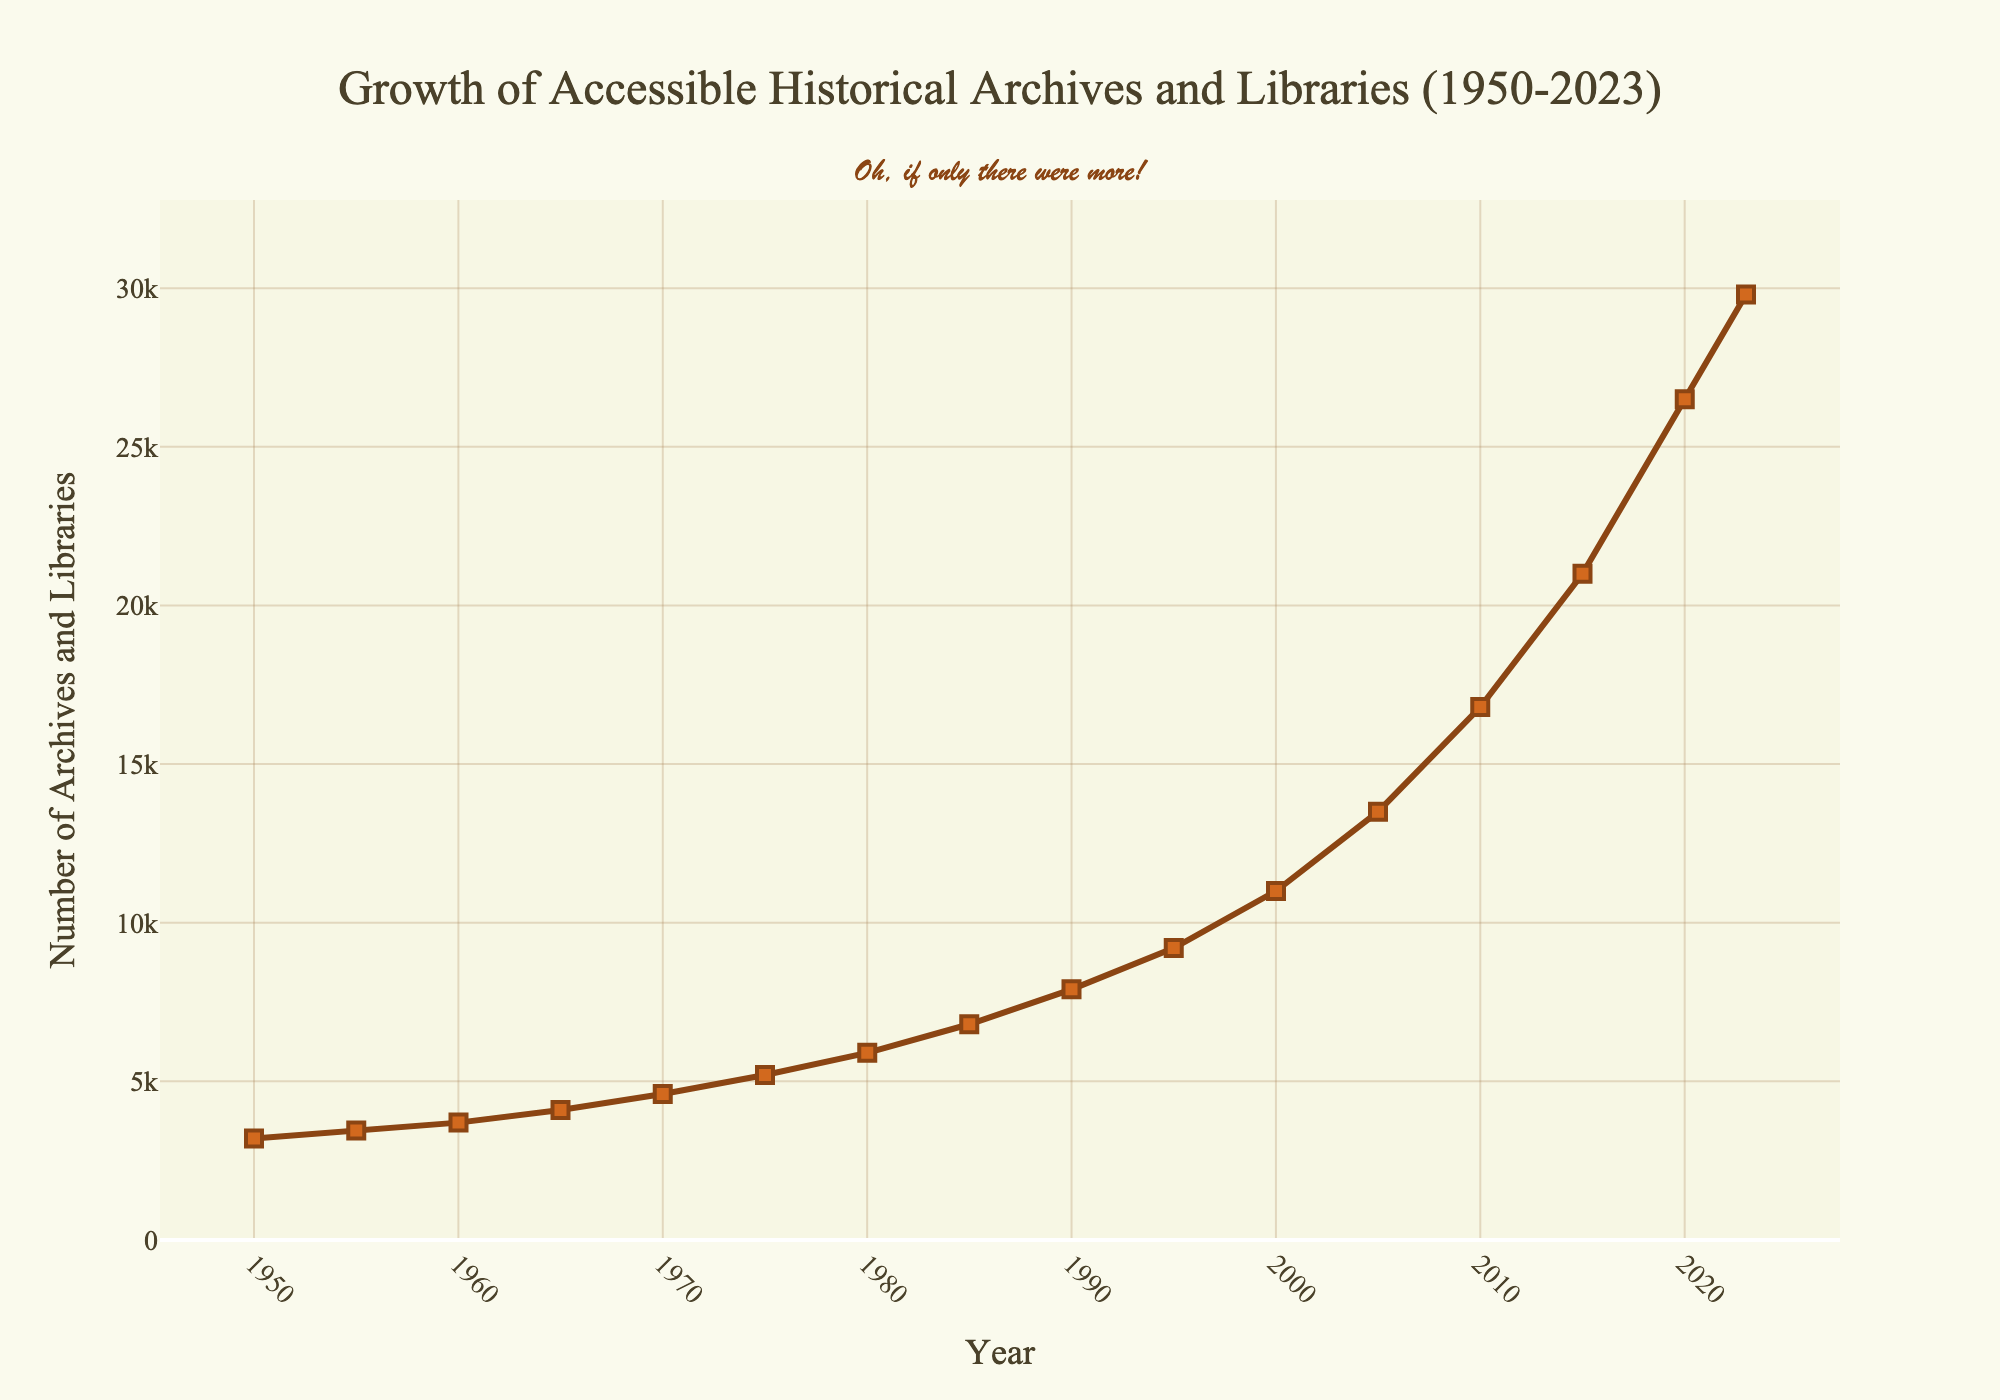What's the overall trend in the number of accessible historical archives and libraries from 1950 to 2023? The line chart shows a consistent increase in the number of accessible historical archives and libraries over the years from 1950 to 2023. Each plotted point is higher than the previous one, indicating growth.
Answer: Consistent increase In which decade did the number of accessible historical archives and libraries see the largest increase? To find this, compare the differences in the number of archives and libraries between each decade. The largest increase appears between 2010 (16,800) and 2020 (26,500), an increase of 9,700.
Answer: 2010 to 2020 What is the difference in the number of accessible historical archives and libraries between 1950 and 2023? Subtract the number of archives and libraries in 1950 (3,200) from the number in 2023 (29,800). 29,800 - 3,200 = 26,600.
Answer: 26,600 How many more accessible historical archives and libraries were there in 2000 compared to 1980? Subtract the number of archives and libraries in 1980 (5,900) from the number in 2000 (11,000). 11,000 - 5,900 = 5,100.
Answer: 5,100 How does the increase rate from 1950 to 1980 compare to the increase rate from 1980 to 2010? From 1950 to 1980, the increase in archives and libraries is 5,900 - 3,200 = 2,700 over 30 years. From 1980 to 2010, the increase is 16,800 - 5,900 = 10,900 over 30 years. The rate of increase from 1980 to 2010 is significantly higher.
Answer: 1980 to 2010 higher Identify the visual element that indicates the number of archives and libraries for each year. The number of archives and libraries for each year is indicated by the position of the square markers along the vertical axis.
Answer: Square markers What is the visual color used for the line connecting the markers? The line connecting the markers is colored brown.
Answer: Brown If the trend continues from 2023, estimate the number of accessible historical archives and libraries in 2025. Observing the sharp increase between 2020 and 2023 (29,800 - 26,500 = 3,300 in 3 years), we project a similar increase for 2 years. It's estimated to be approximately 29,800 + (3,300 / 3 * 2) = 32,000.
Answer: Approximately 32,000 What is the annotation text displayed at the top of the plot? The annotation text at the top of the plot reads, "Oh, if only there were more!"
Answer: "Oh, if only there were more!" 